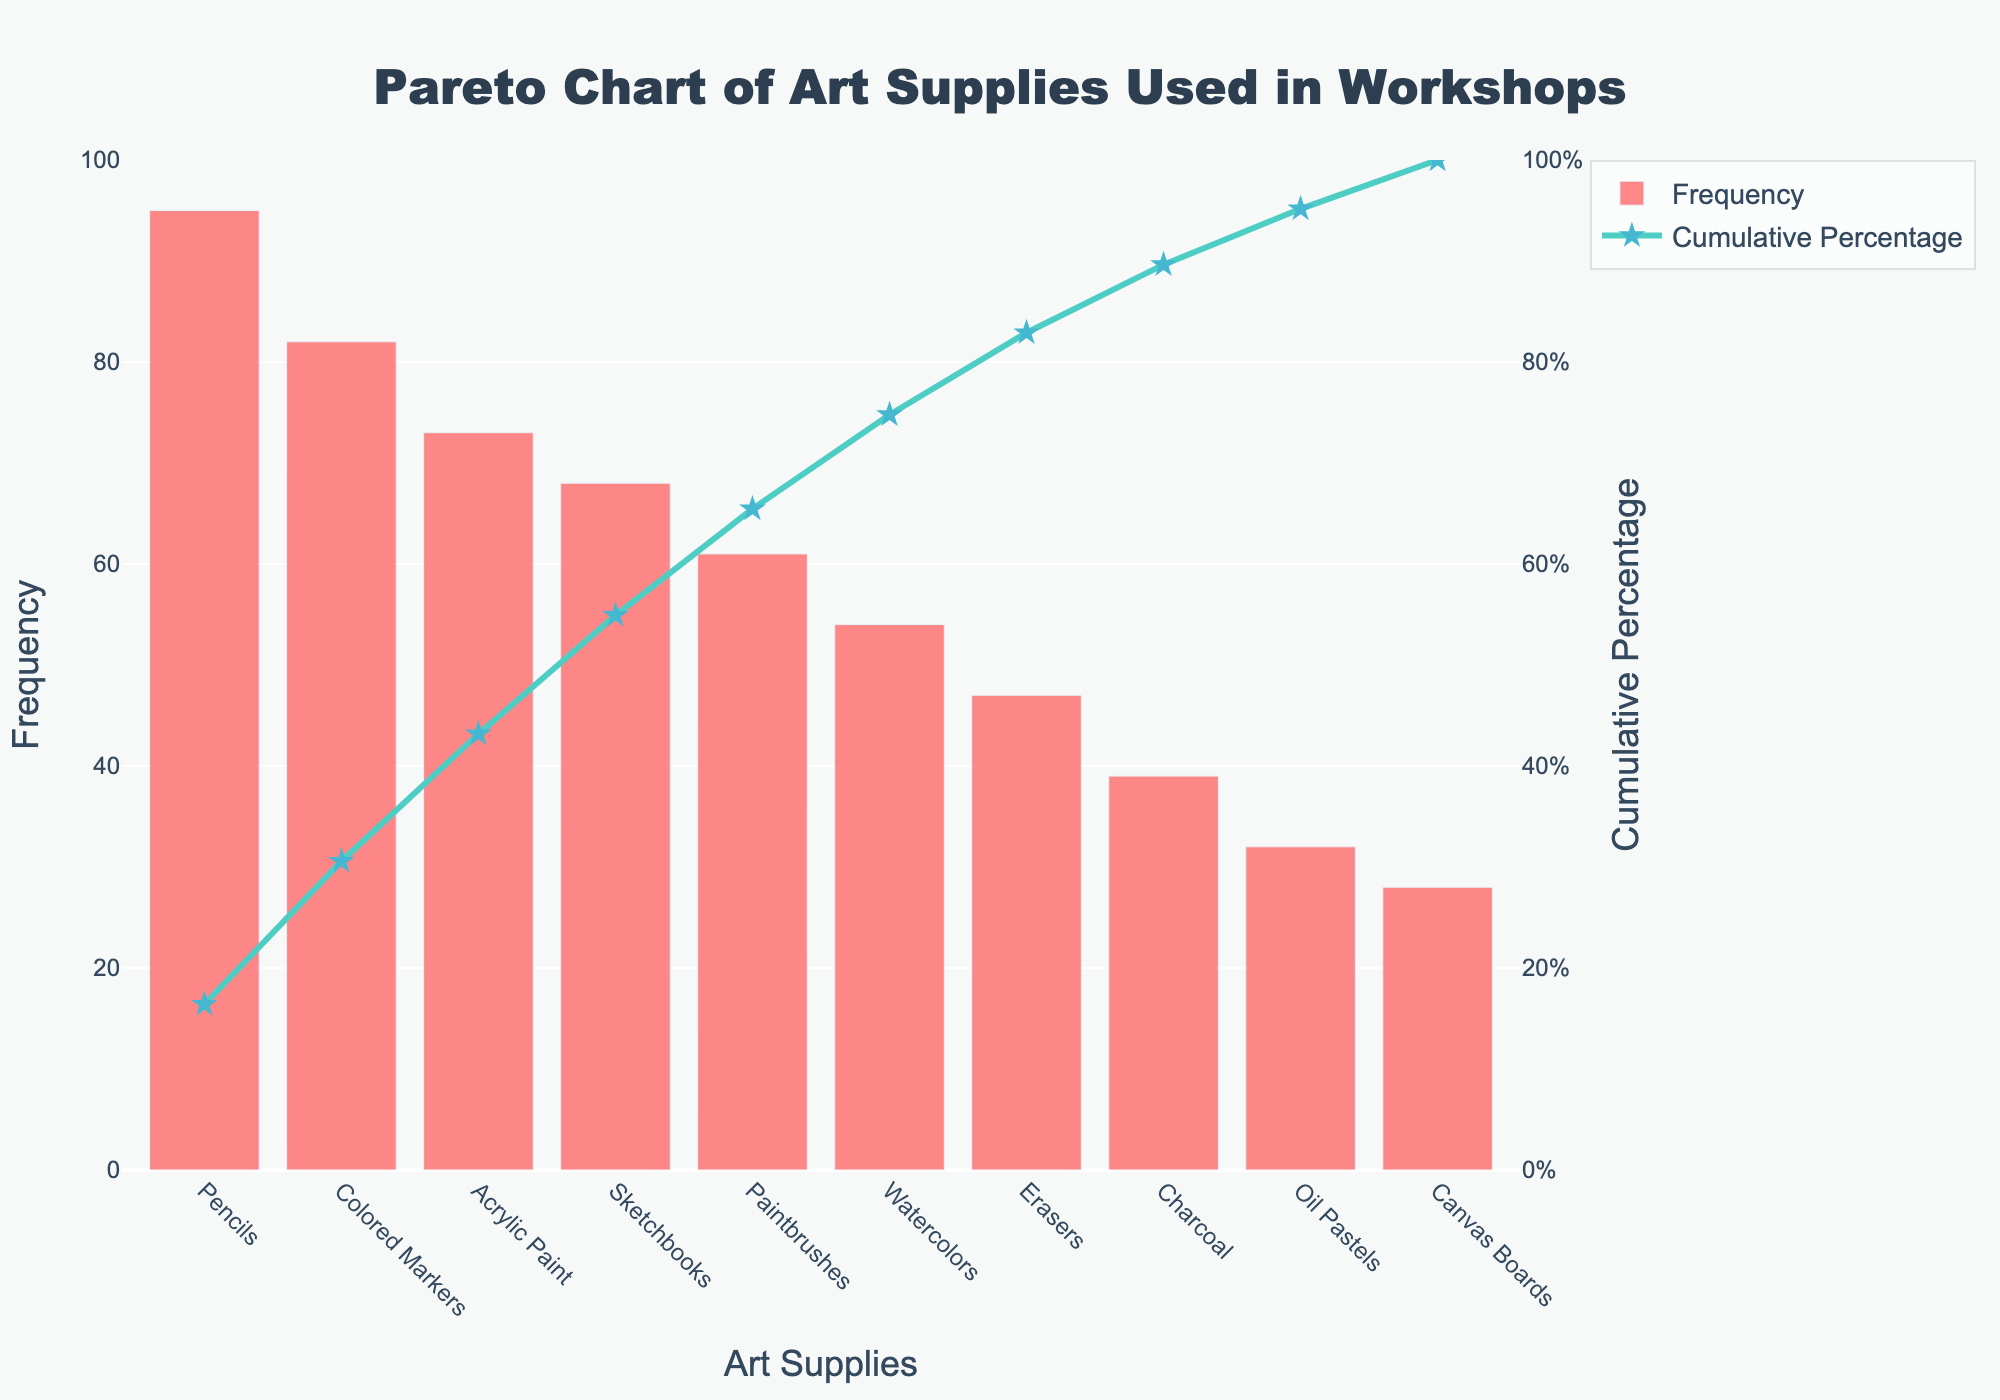What is the title of the plot? The title of the plot is located at the top and should provide a clear overview of what the chart represents. In this case, it is "Pareto Chart of Art Supplies Used in Workshops."
Answer: Pareto Chart of Art Supplies Used in Workshops Which art supply has the highest frequency? Look at the bars on the left side of the chart, identifying the tallest one and reading the corresponding label on the x-axis. The tallest bar represents "Pencils."
Answer: Pencils What is the cumulative percentage of the top three art supplies? To find the cumulative percentage of the top three art supplies, look at the cumulative percentage line. Sum the frequencies of Pencils, Colored Markers, and Acrylic Paint, and then find their cumulative percentage. According to the chart, it’s approximately 73% (Pencils + Colored Markers + Acrylic Paint cumulative).
Answer: 73% How does the frequency of Sketchbooks compare to Paintbrushes? Look at the heights of the bars for Sketchbooks and Paintbrushes. The bar representing Sketchbooks is taller than the one for Paintbrushes. Therefore, the frequency of Sketchbooks is higher.
Answer: Sketchbooks have a higher frequency than Paintbrushes What percentage of the total frequency do the top five art supplies represent? Look at the cumulative percentage line or sum up the cumulative percentages of the top five supplies (Pencils, Colored Markers, Acrylic Paint, Sketchbooks, and Paintbrushes). According to the chart, they represent approximately 90% of the total frequency.
Answer: 90% Which art supply is used least frequently? Find the shortest bar on the bar chart and check the label on the x-axis for the corresponding art supply. The shortest bar represents "Canvas Boards."
Answer: Canvas Boards What is the frequency difference between Acrylic Paint and Watercolors? Look at the heights of the bars for Acrylic Paint and Watercolors. Subtract the frequency of Watercolors from the frequency of Acrylic Paint to find the difference. The frequencies are 73 (Acrylic Paint) and 54 (Watercolors), so the difference is 73 - 54.
Answer: 19 Between Erasers and Charcoal, which one has a higher cumulative percentage? The cumulative percentage line indicates the total cumulative percentage up to each point. Erasers come before Charcoal on the x-axis, indicating a higher cumulative percentage for Erasers.
Answer: Erasers What range is the cumulative percentage axis set to? Look at the right y-axis label and the numbers indicated for the cumulative percentage. The range is from 0 to 100%.
Answer: 0 to 100% If only the top four art supplies are considered, what is their combined frequency? Sum the frequencies of the top four art supplies (Pencils, Colored Markers, Acrylic Paint, and Sketchbooks). The combined frequency is 95 + 82 + 73 + 68.
Answer: 318 